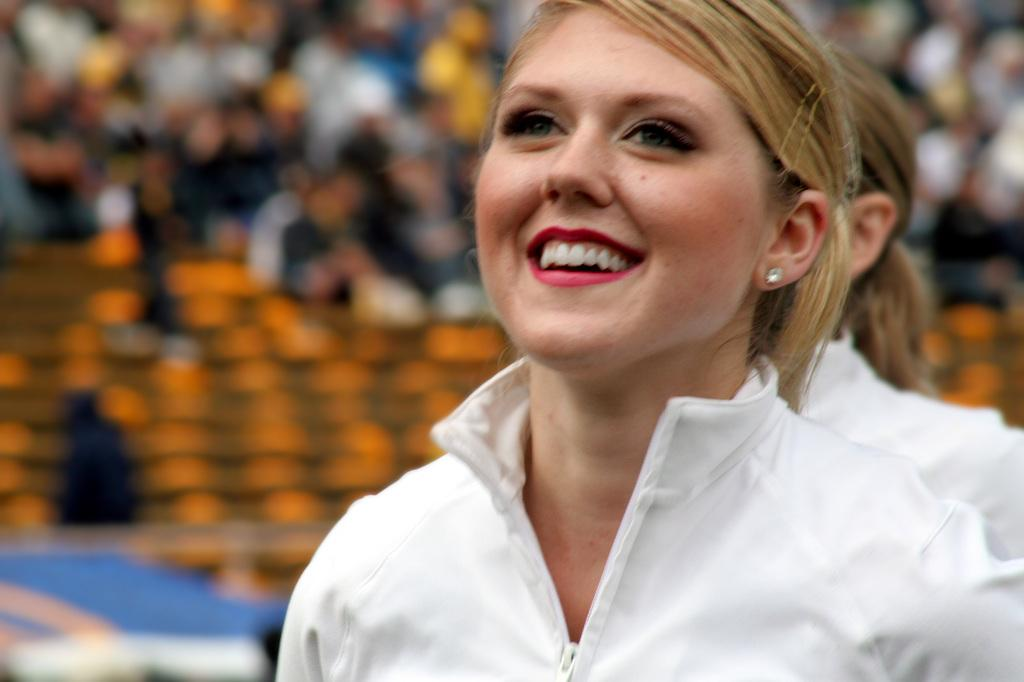How many women are present in the image? There are two women in the image. What are the women wearing? Both women are wearing white dresses. What can be seen in the background of the image? There is a huge crowd in the background of the image. Where might this image have been taken? The image appears to be taken in a stadium. How is the background of the image depicted? The background is blurred. What type of wool is being used to make the women's dresses in the image? There is no mention of wool or any specific fabric in the image; the women are simply wearing white dresses. 